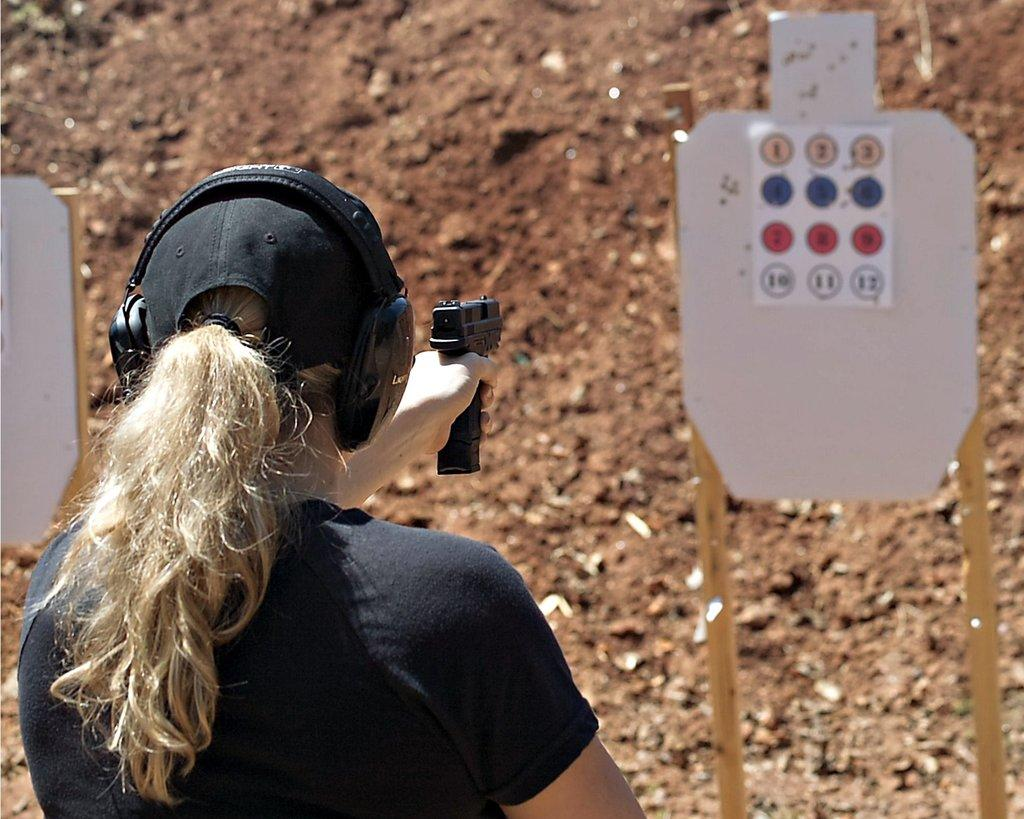What is the person in the image doing? The person is wearing headphones and holding a gun. What might the person be listening to with the headphones? The image does not provide information about what the person is listening to. What can be seen in the background of the image? There are boards, poles, and sand visible in the background of the image. What type of finger food is visible in the image? There is no finger food present in the image. What type of legal advice is the person seeking in the image? The image does not depict any legal advice or a lawyer; it features a person holding a gun and wearing headphones. 